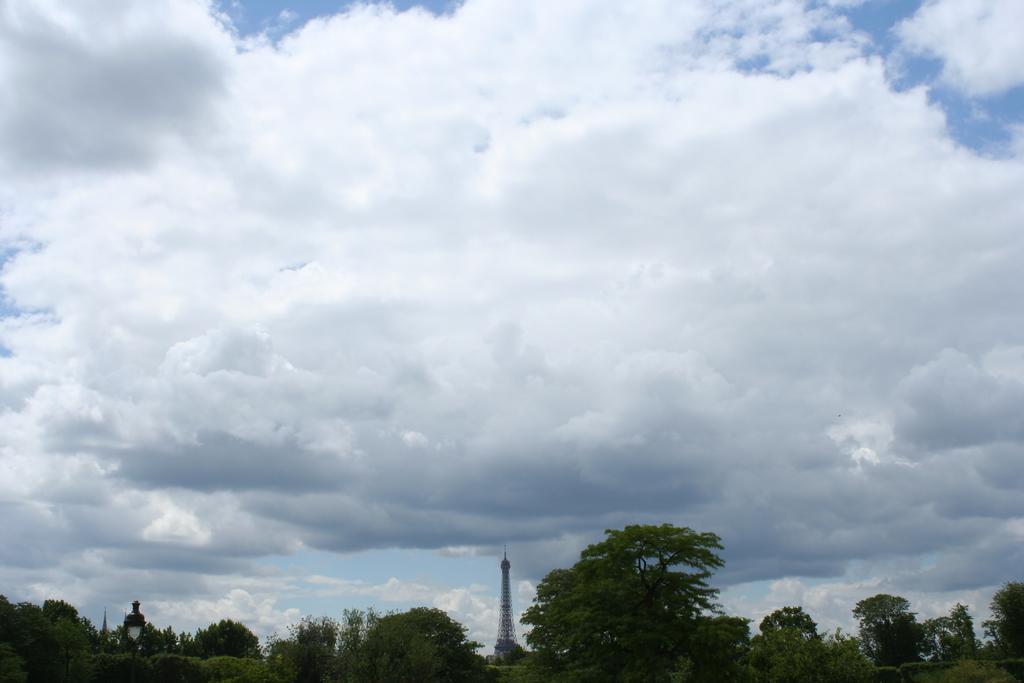Could you give a brief overview of what you see in this image? In the picture we can see some trees, in the background of the picture there is a tower and top of the picture there is cloudy sky. 